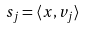Convert formula to latex. <formula><loc_0><loc_0><loc_500><loc_500>s _ { j } = \langle x , v _ { j } \rangle</formula> 